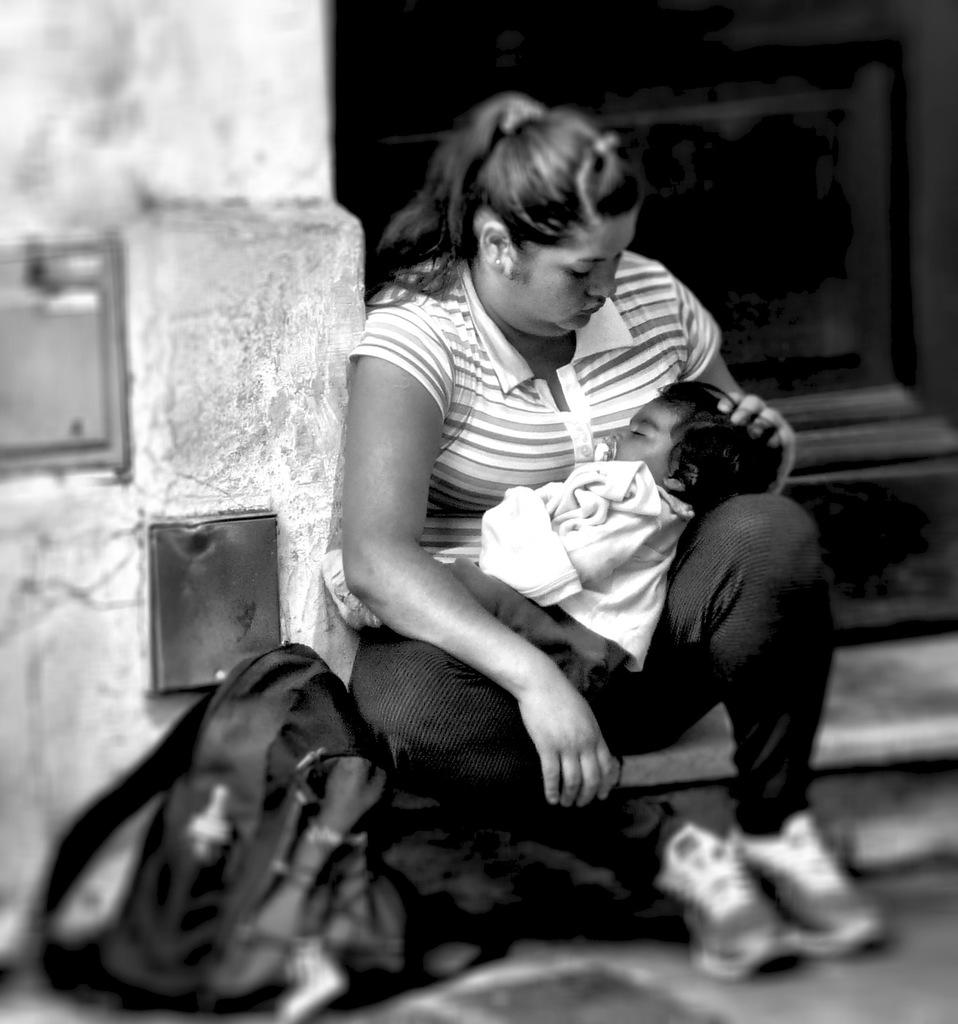What is the color scheme of the image? The image is black and white. What is the woman in the image doing? The woman is holding a baby in the image. What object can be seen besides the woman and baby? There is a bag in the image. What is on the left side of the image? There is a wall on the left side of the image. How would you describe the overall lighting in the image? The background of the image is dark. What type of zinc is being used to burn the baby's clothes in the image? There is no zinc or burning depicted in the image; it shows a woman holding a baby with a bag and a wall in the background. 